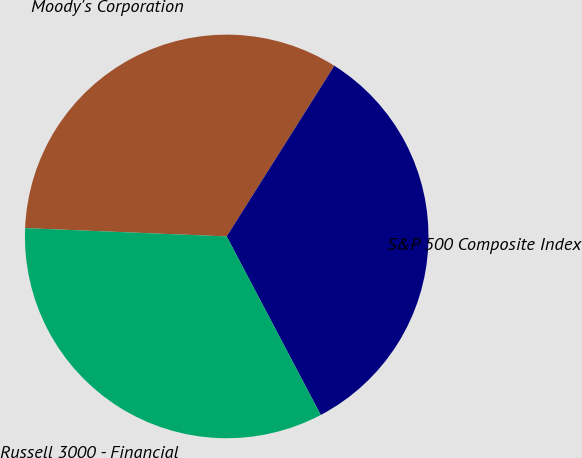<chart> <loc_0><loc_0><loc_500><loc_500><pie_chart><fcel>Moody's Corporation<fcel>S&P 500 Composite Index<fcel>Russell 3000 - Financial<nl><fcel>33.3%<fcel>33.33%<fcel>33.37%<nl></chart> 